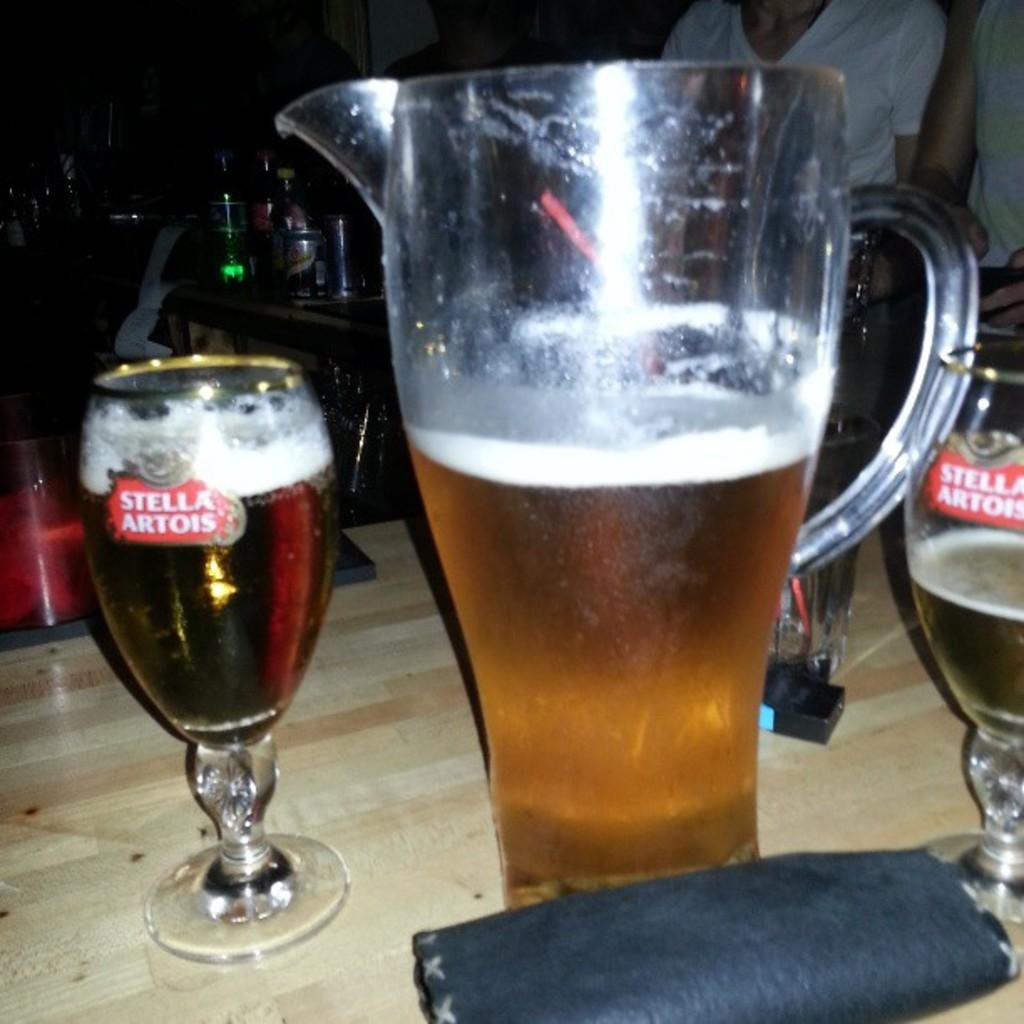<image>
Share a concise interpretation of the image provided. A pitcher of beer is surrounded by Stella Artois glasses on a table. 